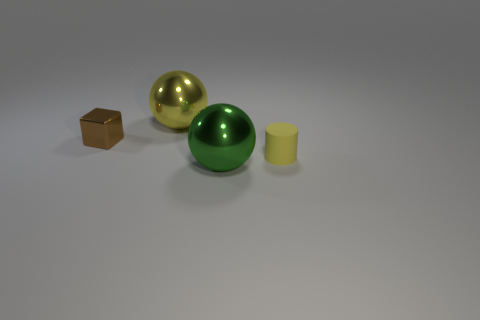Add 4 yellow shiny spheres. How many objects exist? 8 Subtract all yellow spheres. How many spheres are left? 1 Subtract 0 gray spheres. How many objects are left? 4 Subtract all cylinders. How many objects are left? 3 Subtract all brown spheres. Subtract all cyan cylinders. How many spheres are left? 2 Subtract all blue balls. How many blue cylinders are left? 0 Subtract all tiny cyan matte objects. Subtract all balls. How many objects are left? 2 Add 4 yellow rubber cylinders. How many yellow rubber cylinders are left? 5 Add 4 brown metallic things. How many brown metallic things exist? 5 